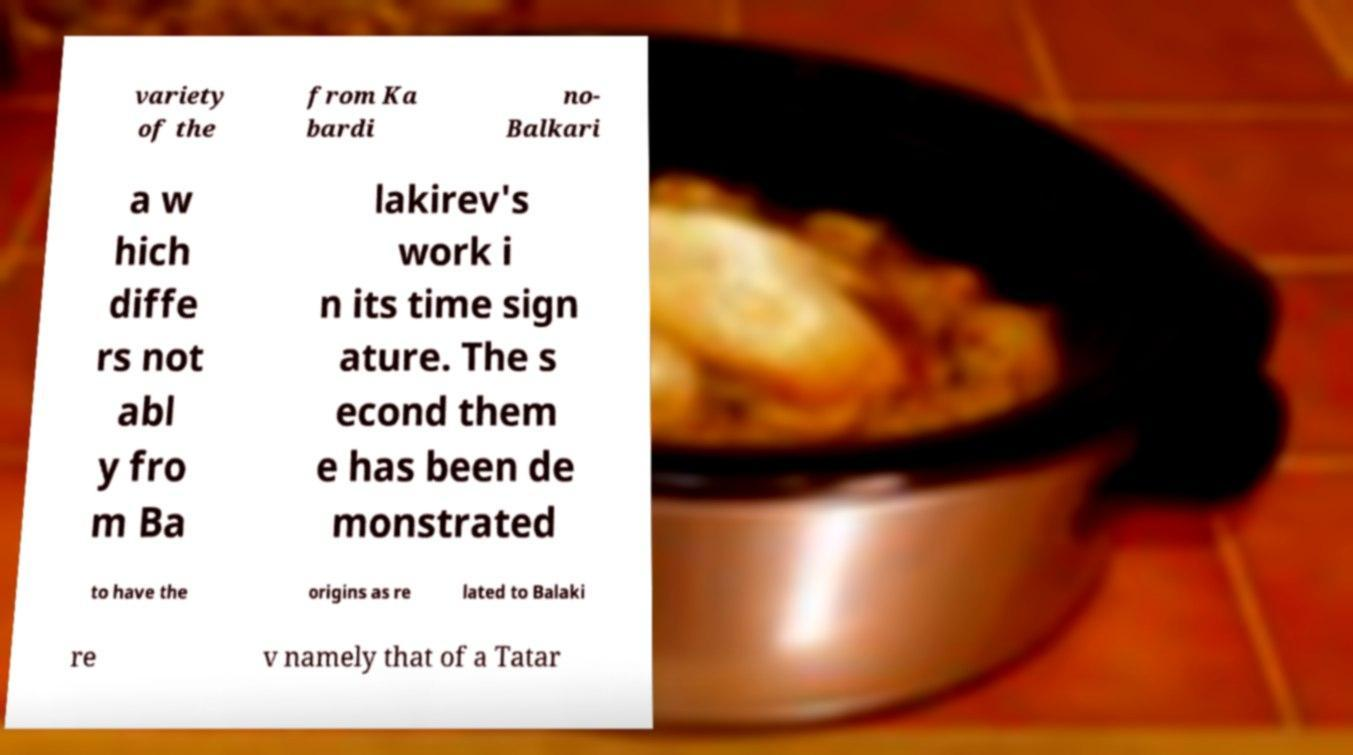Could you assist in decoding the text presented in this image and type it out clearly? variety of the from Ka bardi no- Balkari a w hich diffe rs not abl y fro m Ba lakirev's work i n its time sign ature. The s econd them e has been de monstrated to have the origins as re lated to Balaki re v namely that of a Tatar 